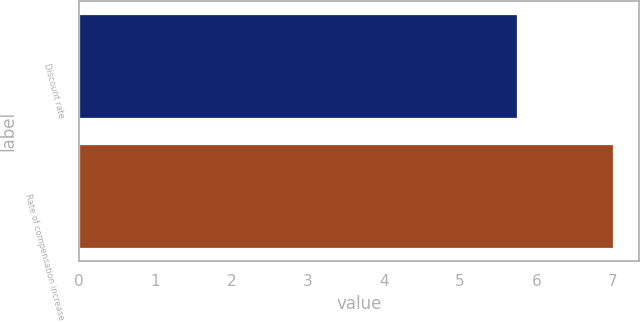<chart> <loc_0><loc_0><loc_500><loc_500><bar_chart><fcel>Discount rate<fcel>Rate of compensation increase<nl><fcel>5.75<fcel>7<nl></chart> 